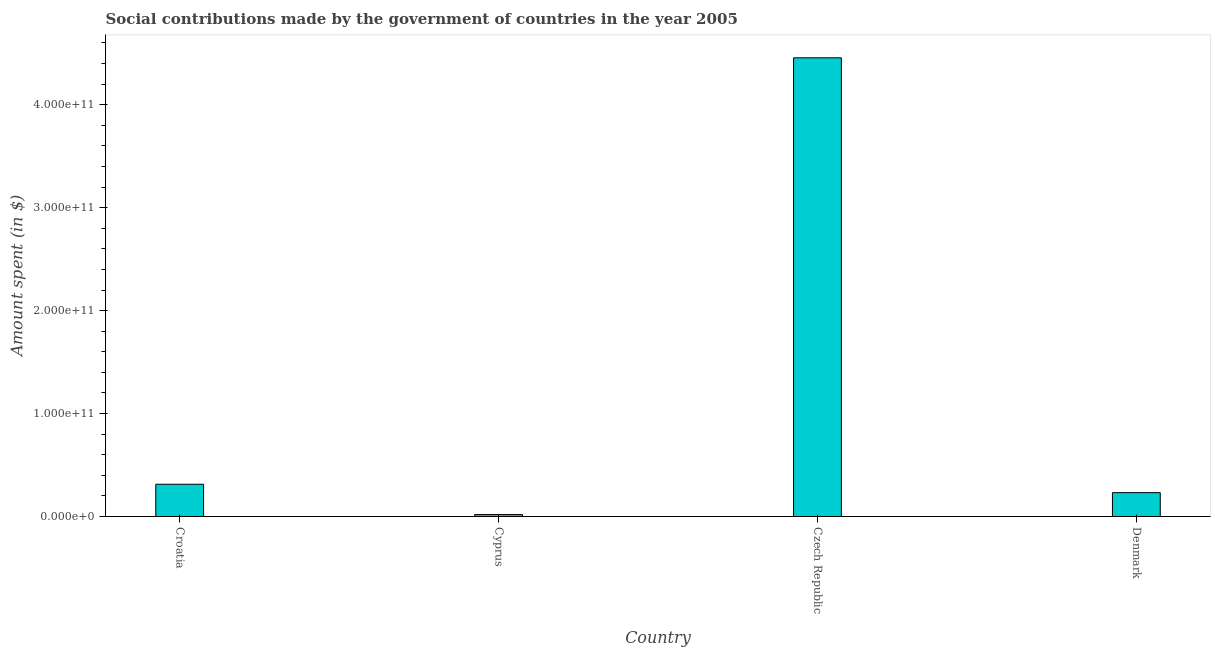Does the graph contain any zero values?
Make the answer very short. No. Does the graph contain grids?
Your answer should be very brief. No. What is the title of the graph?
Make the answer very short. Social contributions made by the government of countries in the year 2005. What is the label or title of the Y-axis?
Provide a succinct answer. Amount spent (in $). What is the amount spent in making social contributions in Denmark?
Keep it short and to the point. 2.32e+1. Across all countries, what is the maximum amount spent in making social contributions?
Provide a short and direct response. 4.46e+11. Across all countries, what is the minimum amount spent in making social contributions?
Keep it short and to the point. 1.90e+09. In which country was the amount spent in making social contributions maximum?
Your answer should be very brief. Czech Republic. In which country was the amount spent in making social contributions minimum?
Ensure brevity in your answer.  Cyprus. What is the sum of the amount spent in making social contributions?
Provide a short and direct response. 5.02e+11. What is the difference between the amount spent in making social contributions in Czech Republic and Denmark?
Offer a terse response. 4.22e+11. What is the average amount spent in making social contributions per country?
Ensure brevity in your answer.  1.25e+11. What is the median amount spent in making social contributions?
Your answer should be compact. 2.72e+1. In how many countries, is the amount spent in making social contributions greater than 340000000000 $?
Your answer should be compact. 1. What is the ratio of the amount spent in making social contributions in Cyprus to that in Czech Republic?
Offer a very short reply. 0. Is the difference between the amount spent in making social contributions in Croatia and Czech Republic greater than the difference between any two countries?
Make the answer very short. No. What is the difference between the highest and the second highest amount spent in making social contributions?
Provide a succinct answer. 4.14e+11. Is the sum of the amount spent in making social contributions in Croatia and Denmark greater than the maximum amount spent in making social contributions across all countries?
Offer a terse response. No. What is the difference between the highest and the lowest amount spent in making social contributions?
Your answer should be very brief. 4.44e+11. In how many countries, is the amount spent in making social contributions greater than the average amount spent in making social contributions taken over all countries?
Provide a short and direct response. 1. How many bars are there?
Offer a very short reply. 4. How many countries are there in the graph?
Your answer should be very brief. 4. What is the difference between two consecutive major ticks on the Y-axis?
Your answer should be very brief. 1.00e+11. Are the values on the major ticks of Y-axis written in scientific E-notation?
Make the answer very short. Yes. What is the Amount spent (in $) of Croatia?
Give a very brief answer. 3.13e+1. What is the Amount spent (in $) of Cyprus?
Your answer should be compact. 1.90e+09. What is the Amount spent (in $) in Czech Republic?
Make the answer very short. 4.46e+11. What is the Amount spent (in $) in Denmark?
Ensure brevity in your answer.  2.32e+1. What is the difference between the Amount spent (in $) in Croatia and Cyprus?
Make the answer very short. 2.94e+1. What is the difference between the Amount spent (in $) in Croatia and Czech Republic?
Your response must be concise. -4.14e+11. What is the difference between the Amount spent (in $) in Croatia and Denmark?
Provide a succinct answer. 8.15e+09. What is the difference between the Amount spent (in $) in Cyprus and Czech Republic?
Make the answer very short. -4.44e+11. What is the difference between the Amount spent (in $) in Cyprus and Denmark?
Your response must be concise. -2.13e+1. What is the difference between the Amount spent (in $) in Czech Republic and Denmark?
Give a very brief answer. 4.22e+11. What is the ratio of the Amount spent (in $) in Croatia to that in Cyprus?
Offer a terse response. 16.49. What is the ratio of the Amount spent (in $) in Croatia to that in Czech Republic?
Give a very brief answer. 0.07. What is the ratio of the Amount spent (in $) in Croatia to that in Denmark?
Your answer should be very brief. 1.35. What is the ratio of the Amount spent (in $) in Cyprus to that in Czech Republic?
Make the answer very short. 0. What is the ratio of the Amount spent (in $) in Cyprus to that in Denmark?
Your response must be concise. 0.08. What is the ratio of the Amount spent (in $) in Czech Republic to that in Denmark?
Provide a short and direct response. 19.24. 